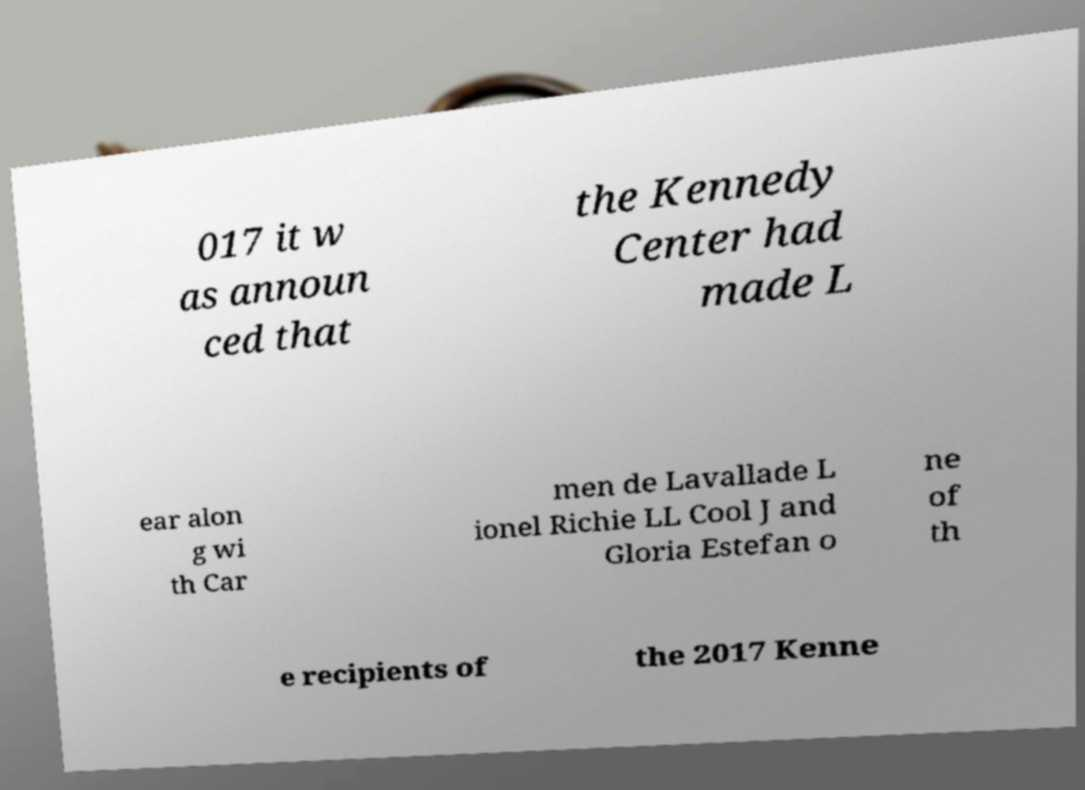Can you accurately transcribe the text from the provided image for me? 017 it w as announ ced that the Kennedy Center had made L ear alon g wi th Car men de Lavallade L ionel Richie LL Cool J and Gloria Estefan o ne of th e recipients of the 2017 Kenne 